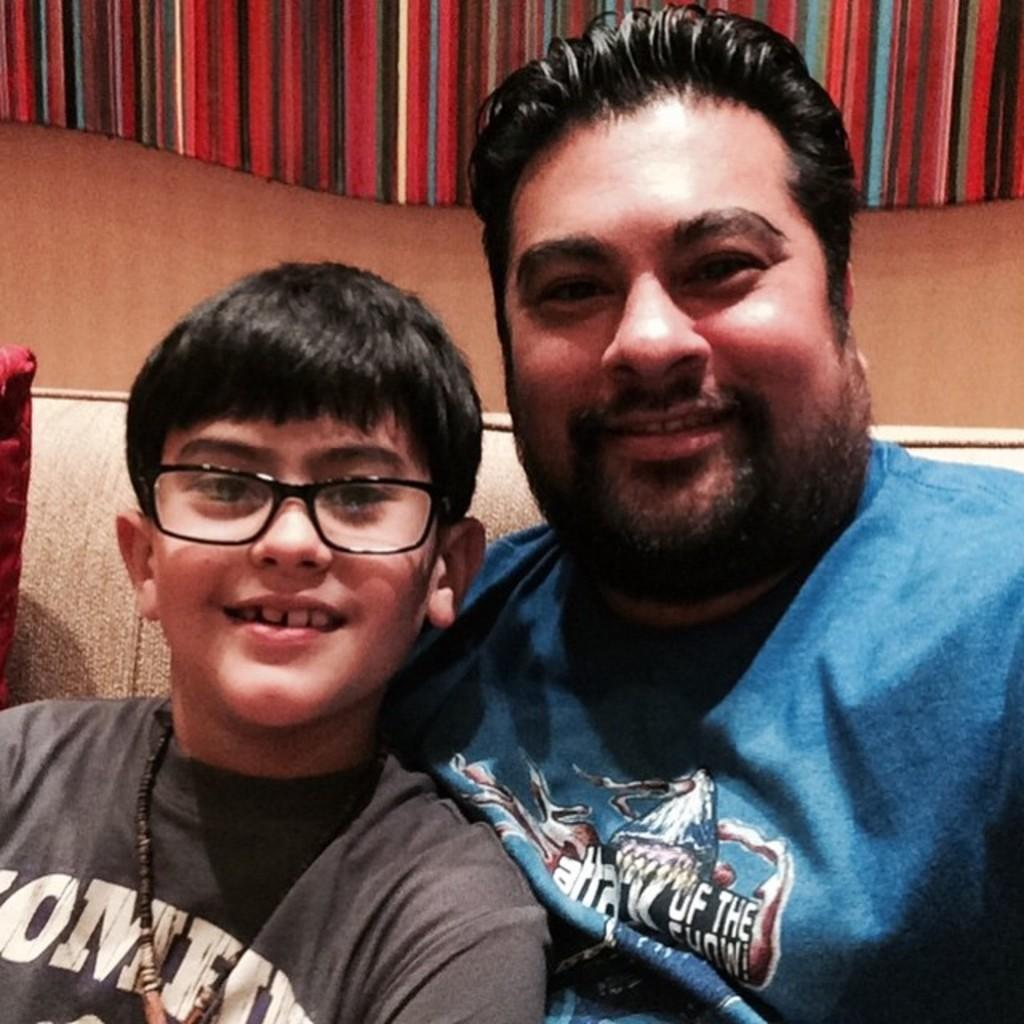Who is present in the image? There is a man and a boy in the image. What is the boy doing in the image? The boy is sitting. Can you describe the boy's appearance in the image? The boy is wearing glasses (specs) in the image. What is the weight of the mom in the image? There is no mom present in the image, so it is not possible to determine her weight. 